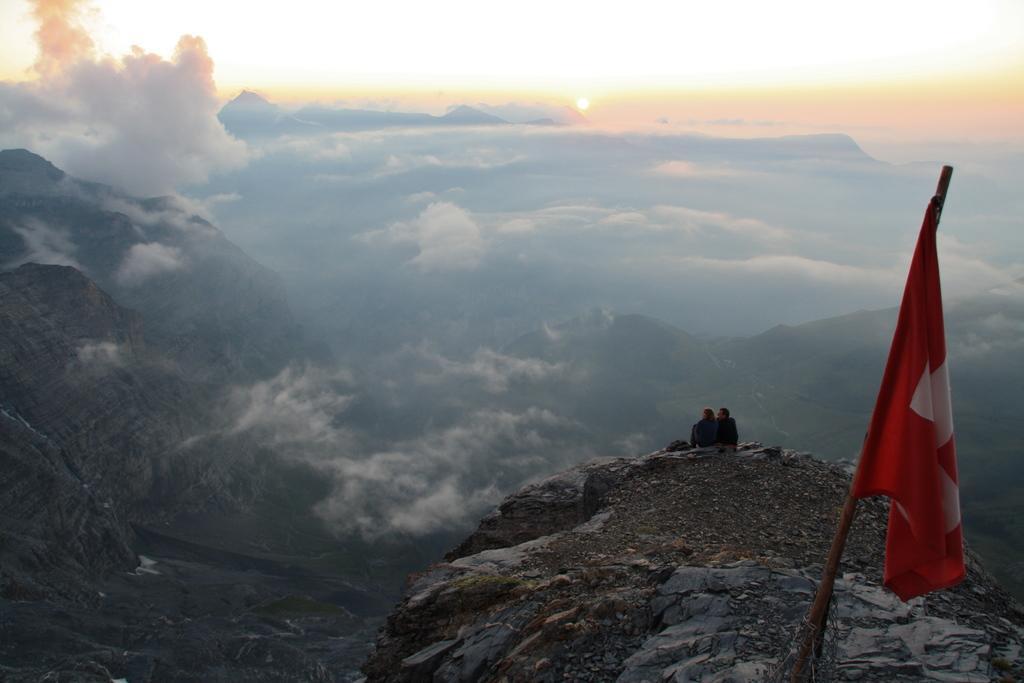Could you give a brief overview of what you see in this image? On the right side of the image we can see a flag, in the background we can find clouds and hills, and also we can see few people are seated. 